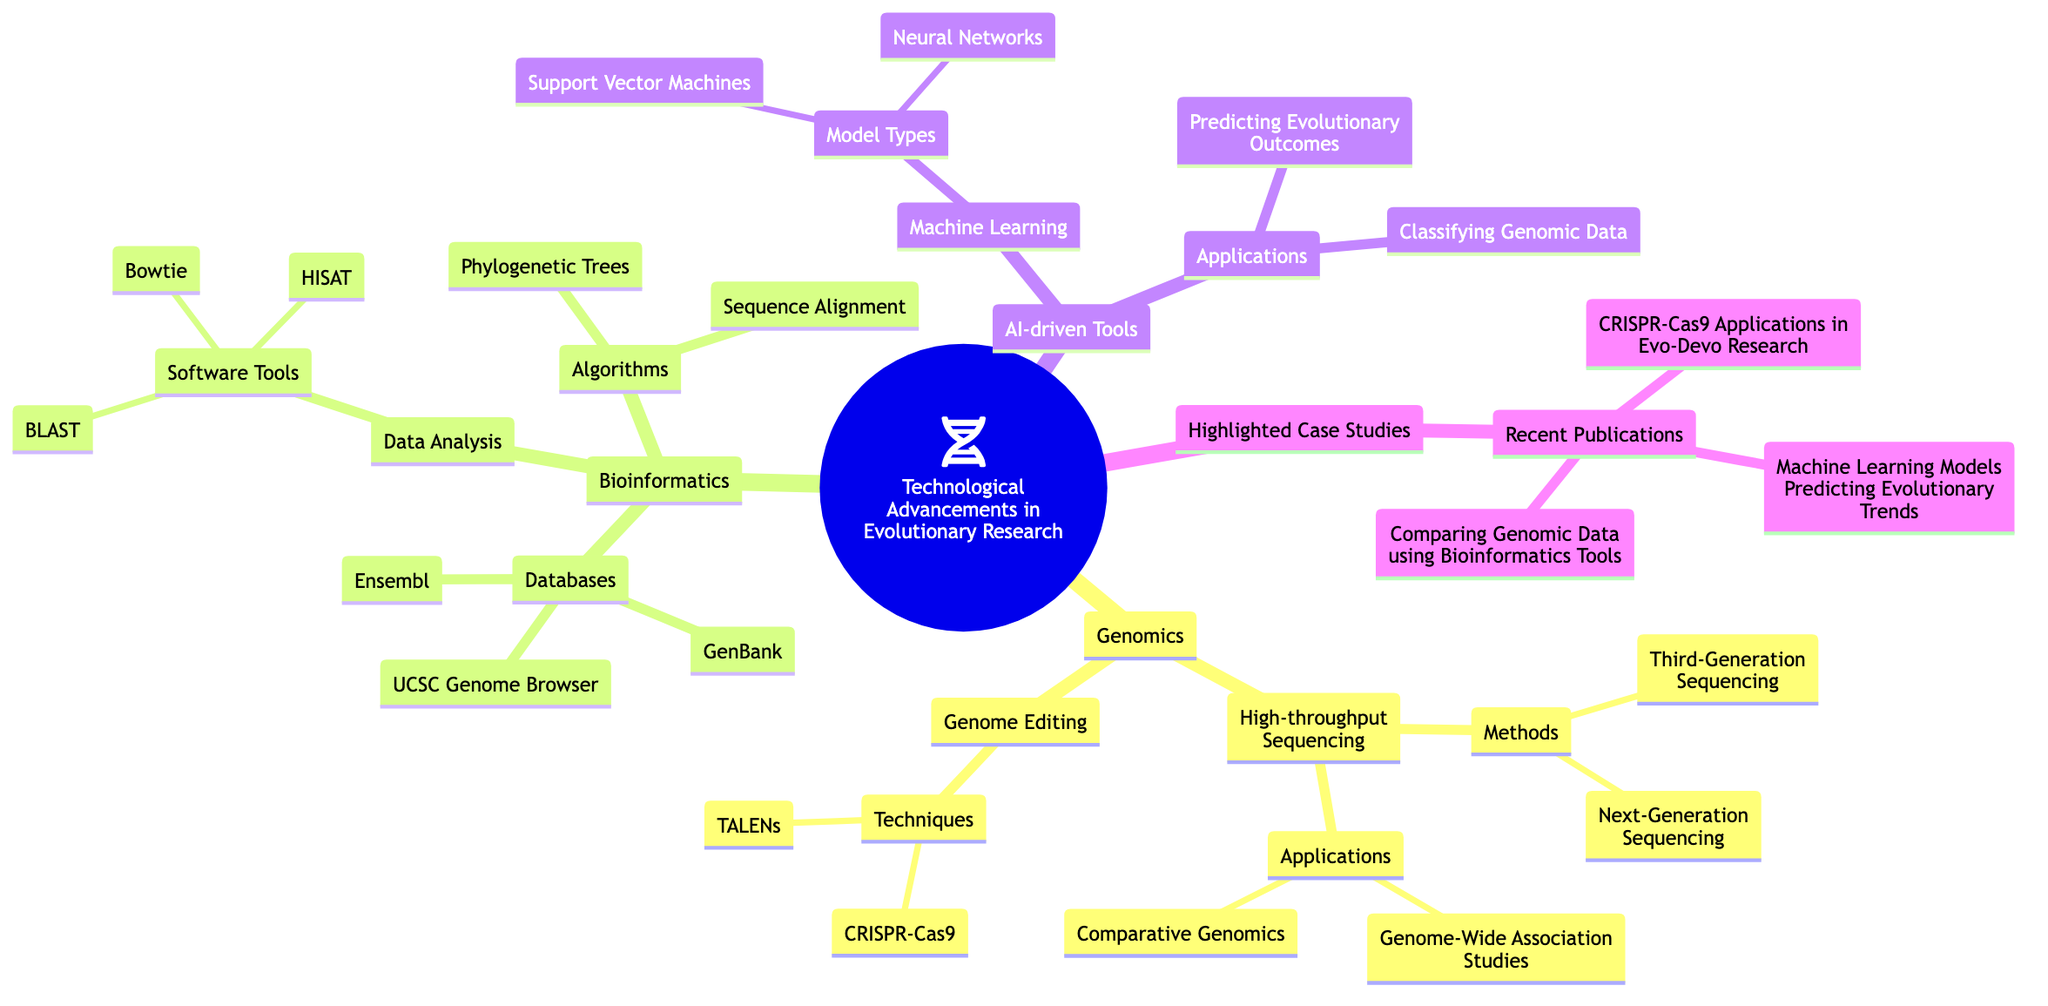What are the two methods under High-throughput Sequencing? The diagram lists "Next-Generation Sequencing" and "Third-Generation Sequencing" under the High-throughput Sequencing section. By directly referencing this section of the mind map, we can identify the two methods clearly.
Answer: Next-Generation Sequencing, Third-Generation Sequencing How many software tools are listed under Data Analysis in Bioinformatics? Under the Data Analysis section of Bioinformatics, there are three software tools mentioned: "BLAST," "Bowtie," and "HISAT." By counting these listed tools, we can determine that there are three of them.
Answer: 3 What is the relationship between Machine Learning and AI-driven Tools? In the diagram, Machine Learning is a subset under AI-driven Tools, indicating that Machine Learning constitutes a part of the broader AI-driven Tools category. This means that Machine Learning encompasses various models and applications which are all classified under AI-driven Tools.
Answer: Machine Learning is a subset Which genomic editing technique is highlighted under Genome Editing? The mind map specifies "CRISPR-Cas9" and "TALENs" as techniques under Genome Editing. Focusing on the term ‘highlighted’ here directs us to the prominent mention of CRISPR-Cas9 as it is widely recognized and often discussed in current research.
Answer: CRISPR-Cas9 What are the applications associated with AI-driven Tools? The diagram presents two specific applications under AI-driven Tools: "Predicting Evolutionary Outcomes" and "Classifying Genomic Data." By reviewing this section, these applications can be directly identified.
Answer: Predicting Evolutionary Outcomes, Classifying Genomic Data How many recent publications are highlighted in the case studies? The case studies section mentions three recent publications: "Paper on CRISPR-Cas9 Applications in Evo-Devo Research," "Study on Machine Learning Models Predicting Evolutionary Trends," and "Research comparing Genomic Data using Bioinformatics Tools." This means there are three highlighted publications overall.
Answer: 3 What type of algorithms are listed under the Bioinformatics section? The algorithms referenced under Bioinformatics include "Phylogenetic Trees" and "Sequence Alignment." These are explicitly mentioned in the diagram, indicating their role in the field of Bioinformatics as algorithms used for analysis.
Answer: Phylogenetic Trees, Sequence Alignment What are the two types of models mentioned in the Machine Learning section? Under the Machine Learning section, "Neural Networks" and "Support Vector Machines" are listed as model types. These terms can be directly extracted from the corresponding section within the mind map.
Answer: Neural Networks, Support Vector Machines 